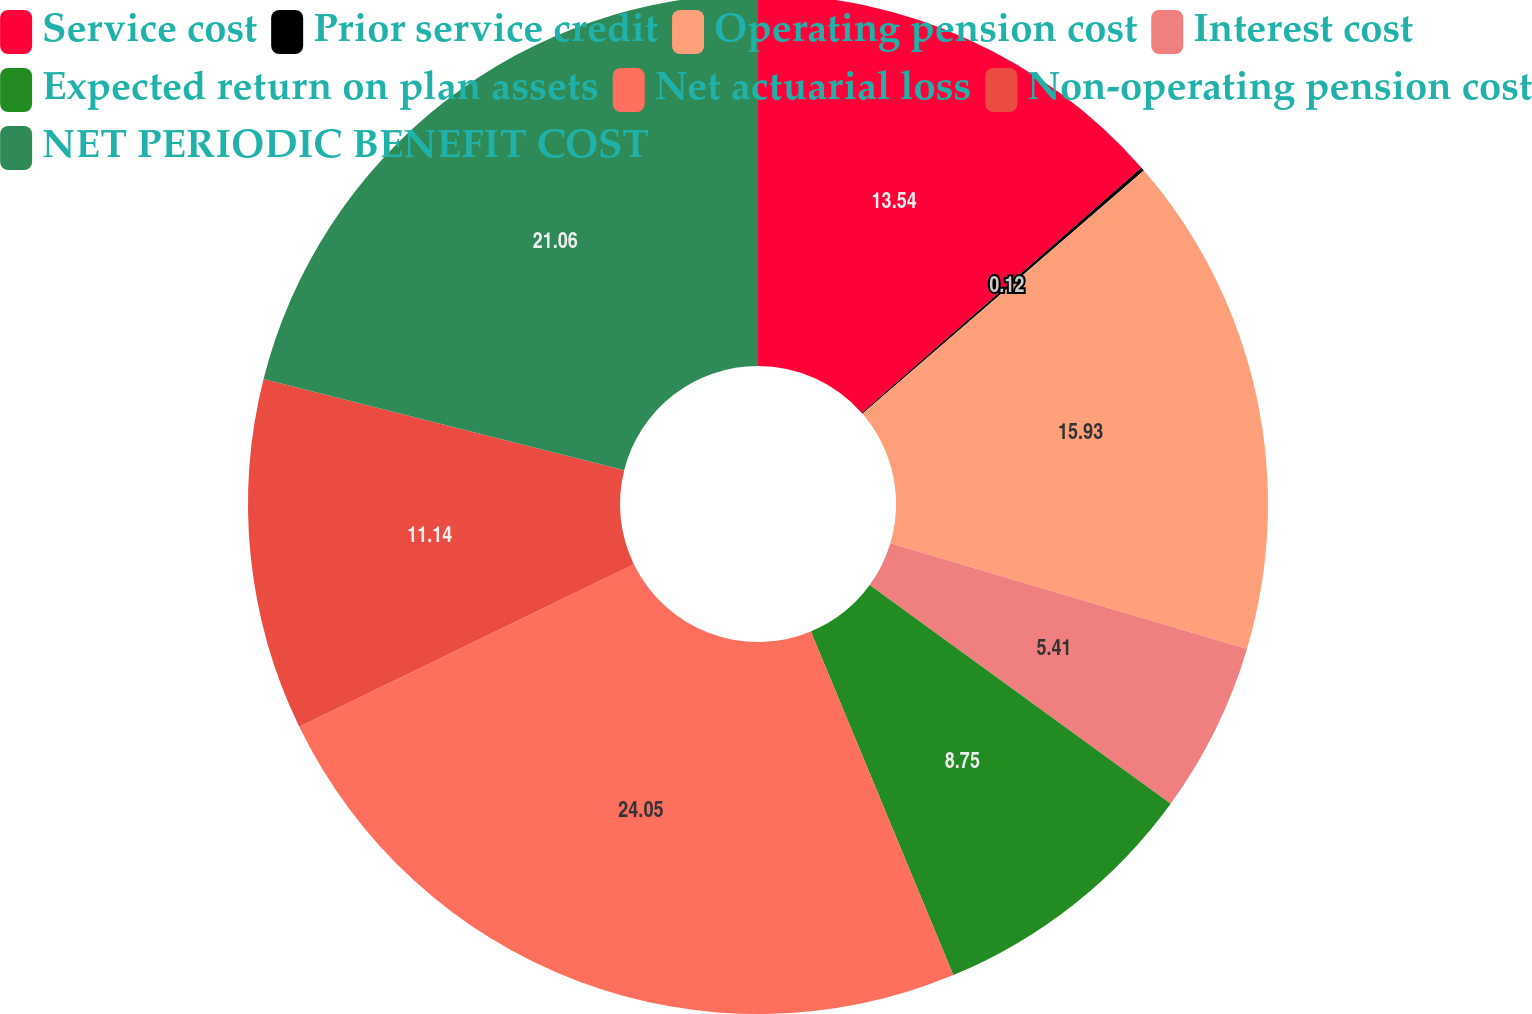Convert chart. <chart><loc_0><loc_0><loc_500><loc_500><pie_chart><fcel>Service cost<fcel>Prior service credit<fcel>Operating pension cost<fcel>Interest cost<fcel>Expected return on plan assets<fcel>Net actuarial loss<fcel>Non-operating pension cost<fcel>NET PERIODIC BENEFIT COST<nl><fcel>13.54%<fcel>0.12%<fcel>15.93%<fcel>5.41%<fcel>8.75%<fcel>24.06%<fcel>11.14%<fcel>21.06%<nl></chart> 